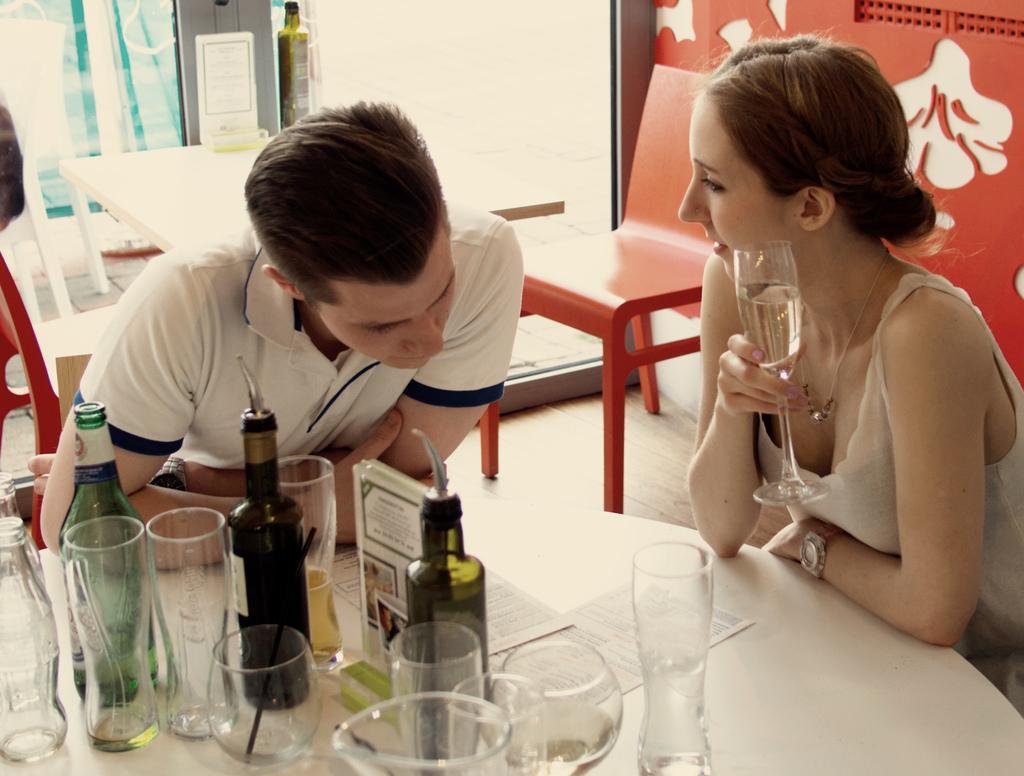How would you summarize this image in a sentence or two? In the image there is a woman and man sitting around table with wine glasses,bottles and papers on it, in the back there are tables and chairs, this seems to be in a restaurant. 